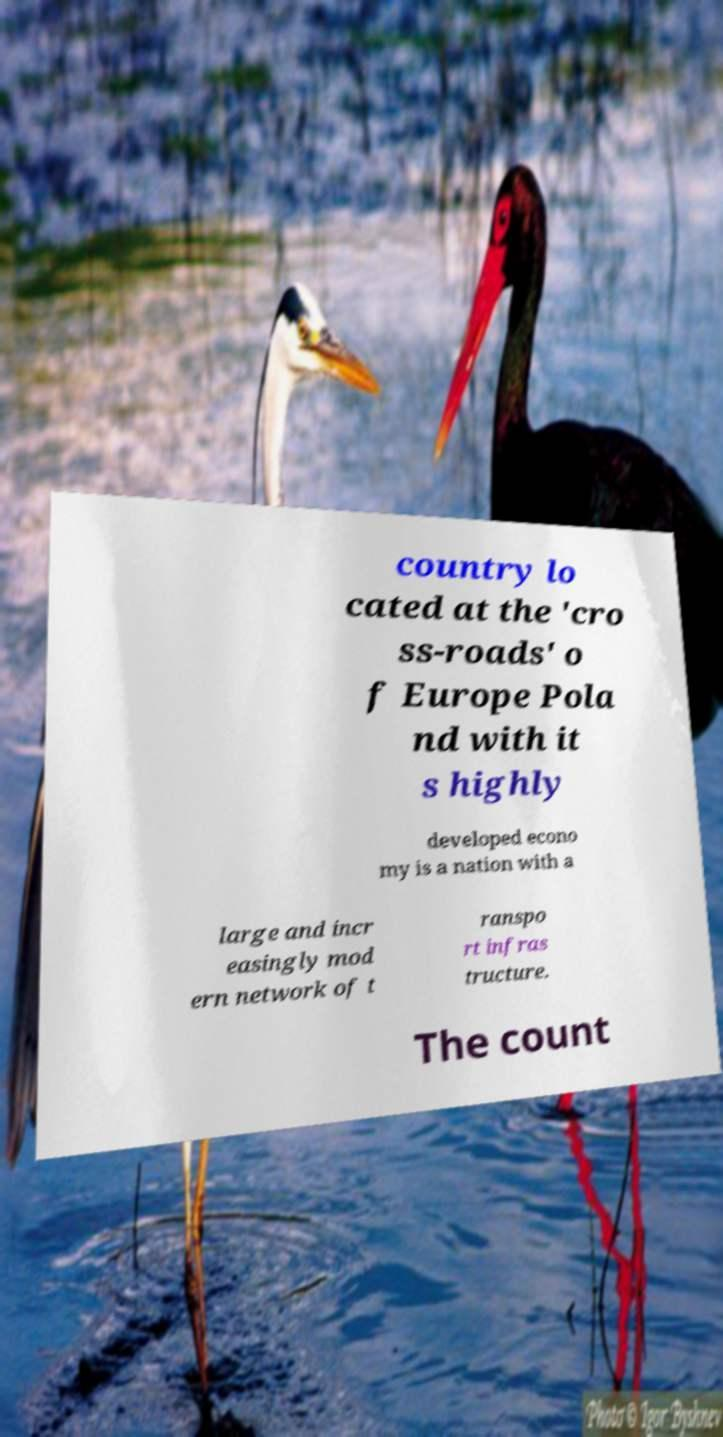Please identify and transcribe the text found in this image. country lo cated at the 'cro ss-roads' o f Europe Pola nd with it s highly developed econo my is a nation with a large and incr easingly mod ern network of t ranspo rt infras tructure. The count 